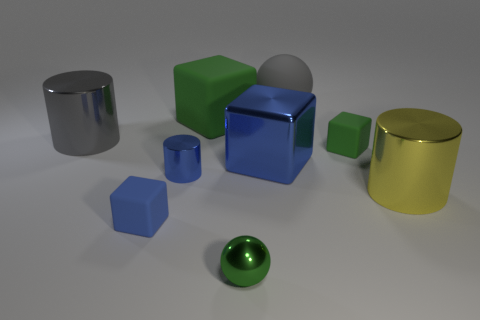Subtract all small blue rubber blocks. How many blocks are left? 3 Subtract all yellow cylinders. How many green blocks are left? 2 Add 1 tiny green rubber blocks. How many objects exist? 10 Subtract 1 balls. How many balls are left? 1 Subtract all cylinders. How many objects are left? 6 Subtract all gray cubes. Subtract all brown cylinders. How many cubes are left? 4 Subtract all green metal cubes. Subtract all small metal cylinders. How many objects are left? 8 Add 8 big blue metallic things. How many big blue metallic things are left? 9 Add 6 matte balls. How many matte balls exist? 7 Subtract 0 green cylinders. How many objects are left? 9 